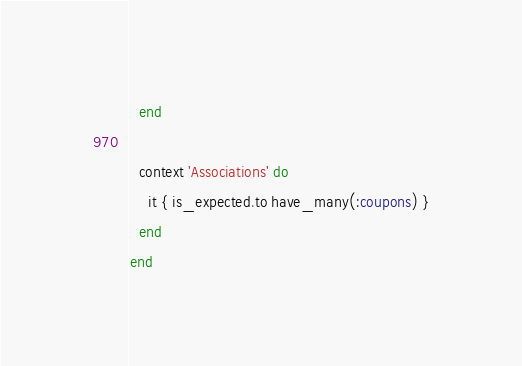Convert code to text. <code><loc_0><loc_0><loc_500><loc_500><_Ruby_>  end

  context 'Associations' do
    it { is_expected.to have_many(:coupons) }
  end
end
</code> 